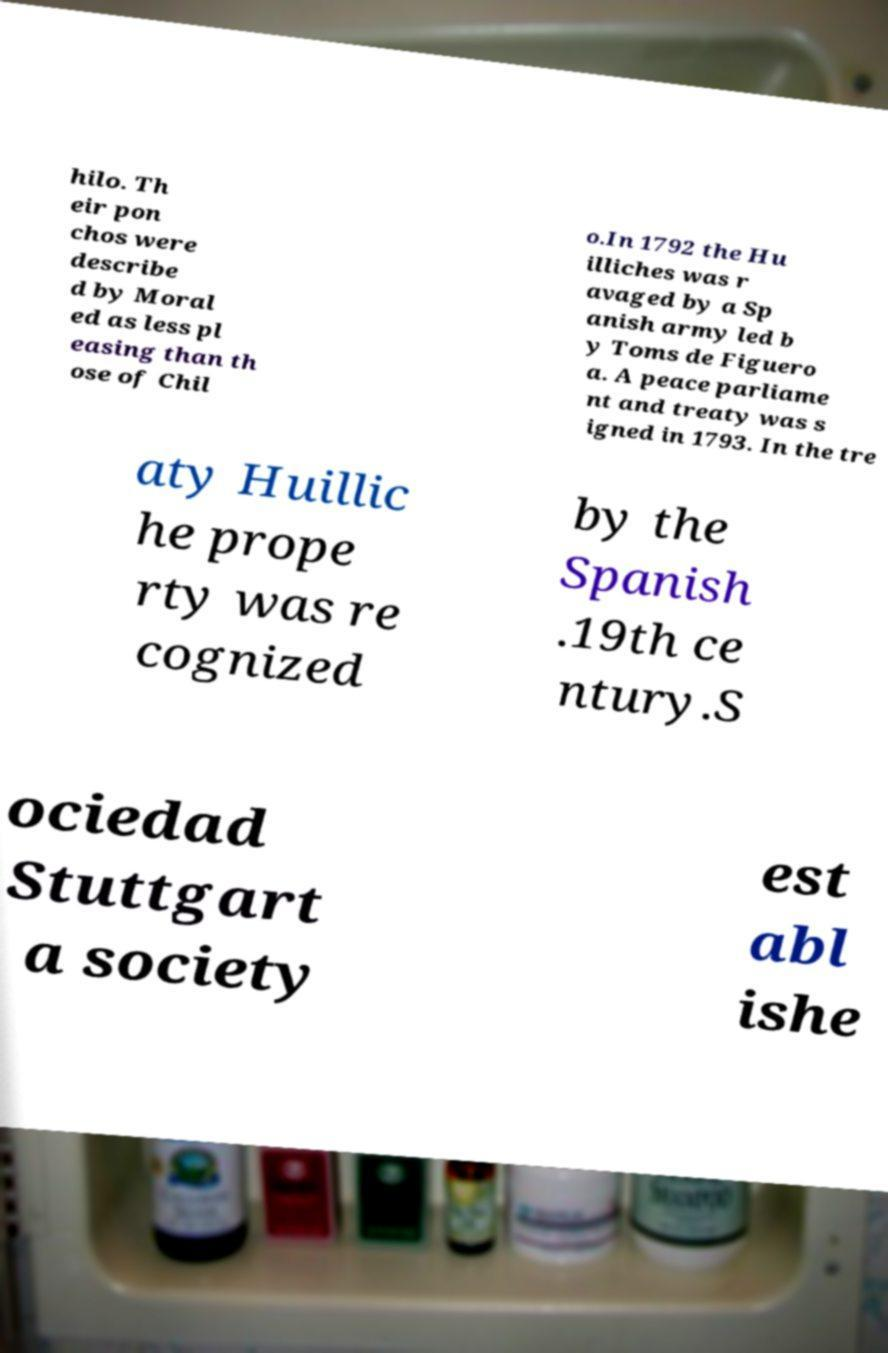Please identify and transcribe the text found in this image. hilo. Th eir pon chos were describe d by Moral ed as less pl easing than th ose of Chil o.In 1792 the Hu illiches was r avaged by a Sp anish army led b y Toms de Figuero a. A peace parliame nt and treaty was s igned in 1793. In the tre aty Huillic he prope rty was re cognized by the Spanish .19th ce ntury.S ociedad Stuttgart a society est abl ishe 